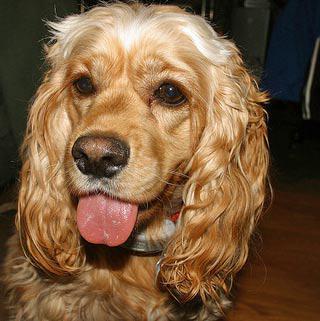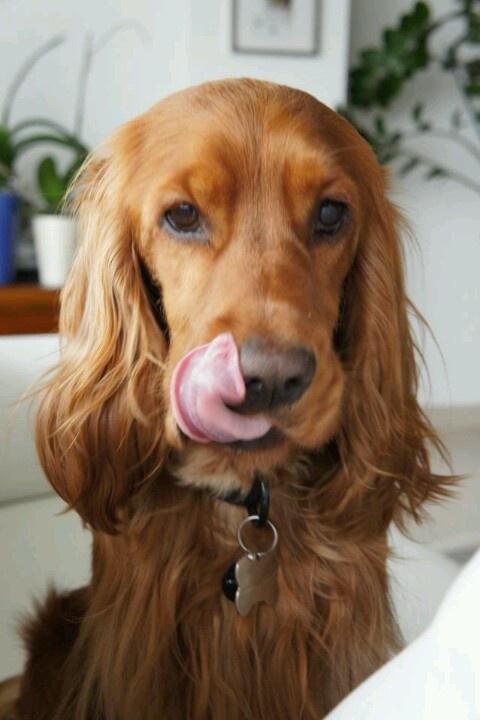The first image is the image on the left, the second image is the image on the right. For the images displayed, is the sentence "The dog in the image on the left is lying on a grey material." factually correct? Answer yes or no. No. The first image is the image on the left, the second image is the image on the right. Evaluate the accuracy of this statement regarding the images: "An image shows one dog with its head resting on some type of grey soft surface.". Is it true? Answer yes or no. No. 